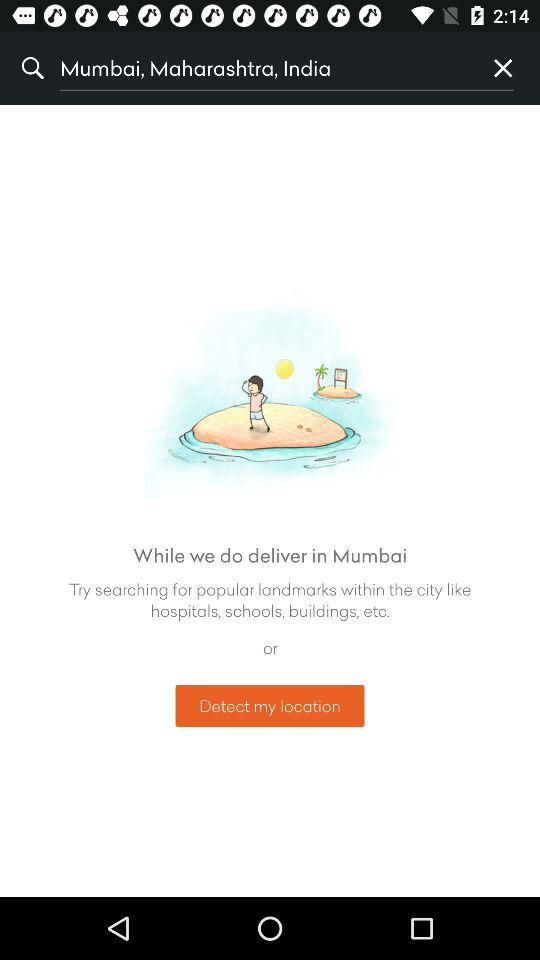What is the input text entered in the search bar? The input text entered in the search bar is "Mumbai, Maharashtra, India". 